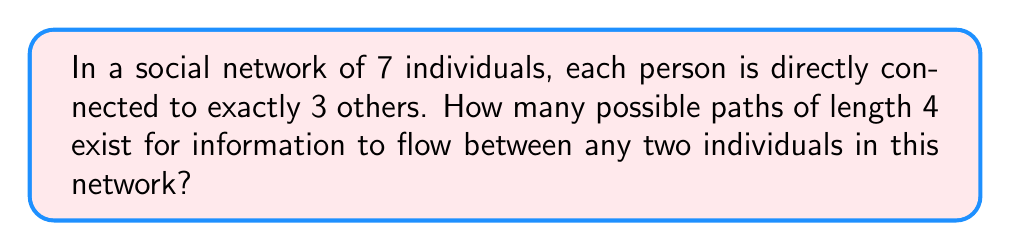Provide a solution to this math problem. Let's approach this step-by-step:

1) First, we need to understand what a path of length 4 means in this context. It's a sequence of 5 individuals, where each consecutive pair is directly connected.

2) To count the number of such paths, we can use the multiplication principle:
   - We have 7 choices for the starting individual
   - For each of the next 4 steps, we have 3 choices (as each person is connected to 3 others)

3) Therefore, the total number of paths of length 4 is:

   $$7 \times 3 \times 3 \times 3 \times 3 = 7 \times 3^4$$

4) Let's calculate this:
   $$7 \times 3^4 = 7 \times 81 = 567$$

5) However, this count includes paths that backtrack (e.g., A-B-A-B-C). In a real information flow scenario, backtracking is usually not considered.

6) To exclude backtracking:
   - For the first step, we still have 3 choices
   - For each subsequent step, we have 2 choices (can't go back)

7) So, the correct calculation is:

   $$7 \times 3 \times 2 \times 2 \times 2 = 7 \times 3 \times 2^3$$

8) Let's calculate this:
   $$7 \times 3 \times 2^3 = 7 \times 3 \times 8 = 168$$

Thus, there are 168 possible non-backtracking paths of length 4 in this network.
Answer: 168 